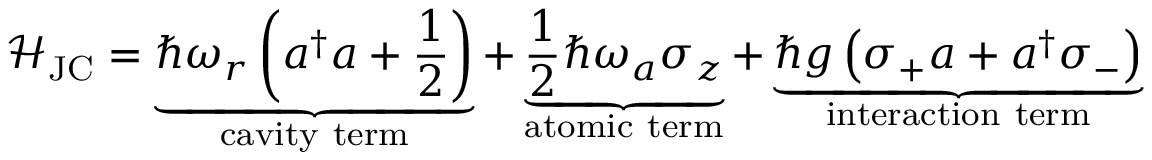Convert formula to latex. <formula><loc_0><loc_0><loc_500><loc_500>{ \mathcal { H } } _ { J C } = \underbrace { \hbar { \omega } _ { r } \left ( a ^ { \dagger } a + { \frac { 1 } { 2 } } \right ) } _ { c a v i t y t e r m } + \underbrace { { \frac { 1 } { 2 } } \hbar { \omega } _ { a } \sigma _ { z } } _ { a t o m i c t e r m } + \underbrace { \hbar { g } \left ( \sigma _ { + } a + a ^ { \dagger } \sigma _ { - } \right ) } _ { i n t e r a c t i o n t e r m }</formula> 